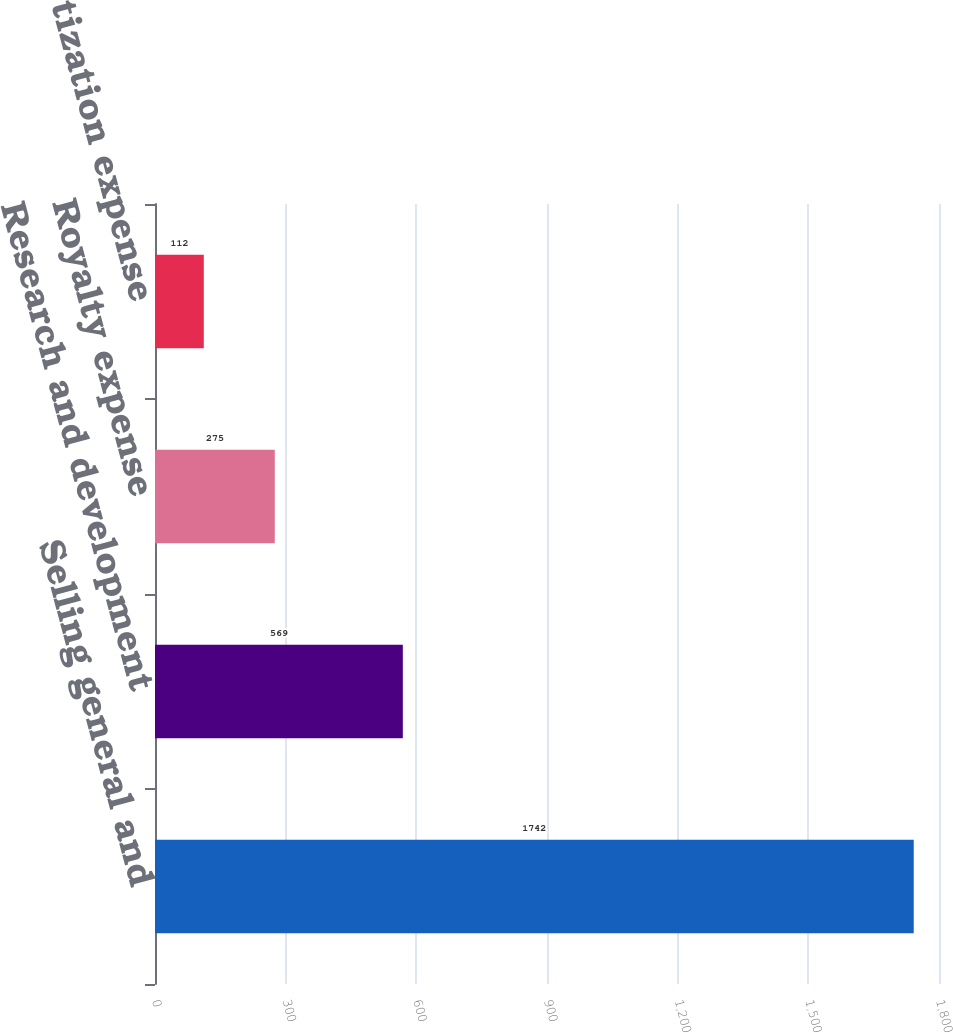Convert chart to OTSL. <chart><loc_0><loc_0><loc_500><loc_500><bar_chart><fcel>Selling general and<fcel>Research and development<fcel>Royalty expense<fcel>Amortization expense<nl><fcel>1742<fcel>569<fcel>275<fcel>112<nl></chart> 